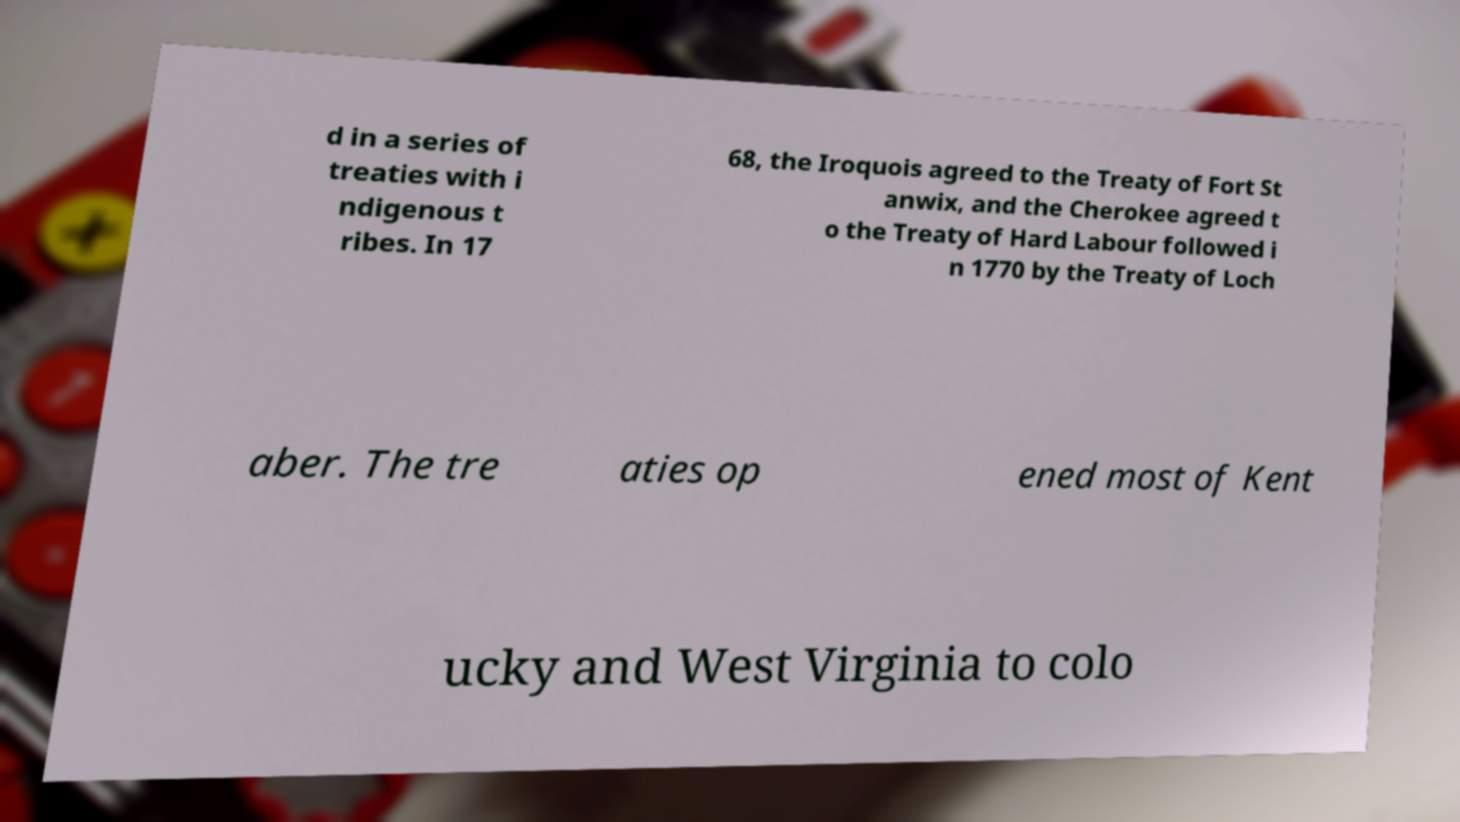I need the written content from this picture converted into text. Can you do that? d in a series of treaties with i ndigenous t ribes. In 17 68, the Iroquois agreed to the Treaty of Fort St anwix, and the Cherokee agreed t o the Treaty of Hard Labour followed i n 1770 by the Treaty of Loch aber. The tre aties op ened most of Kent ucky and West Virginia to colo 